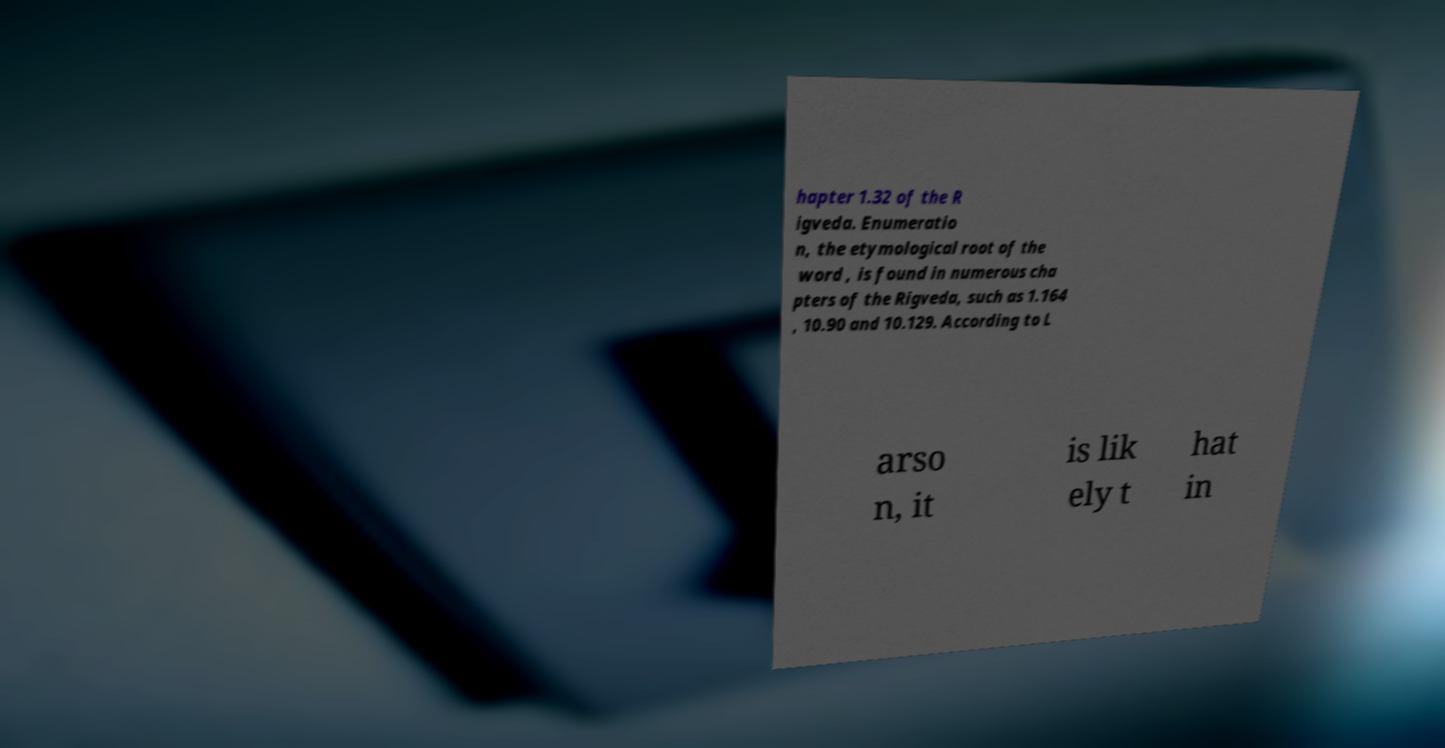Please read and relay the text visible in this image. What does it say? hapter 1.32 of the R igveda. Enumeratio n, the etymological root of the word , is found in numerous cha pters of the Rigveda, such as 1.164 , 10.90 and 10.129. According to L arso n, it is lik ely t hat in 